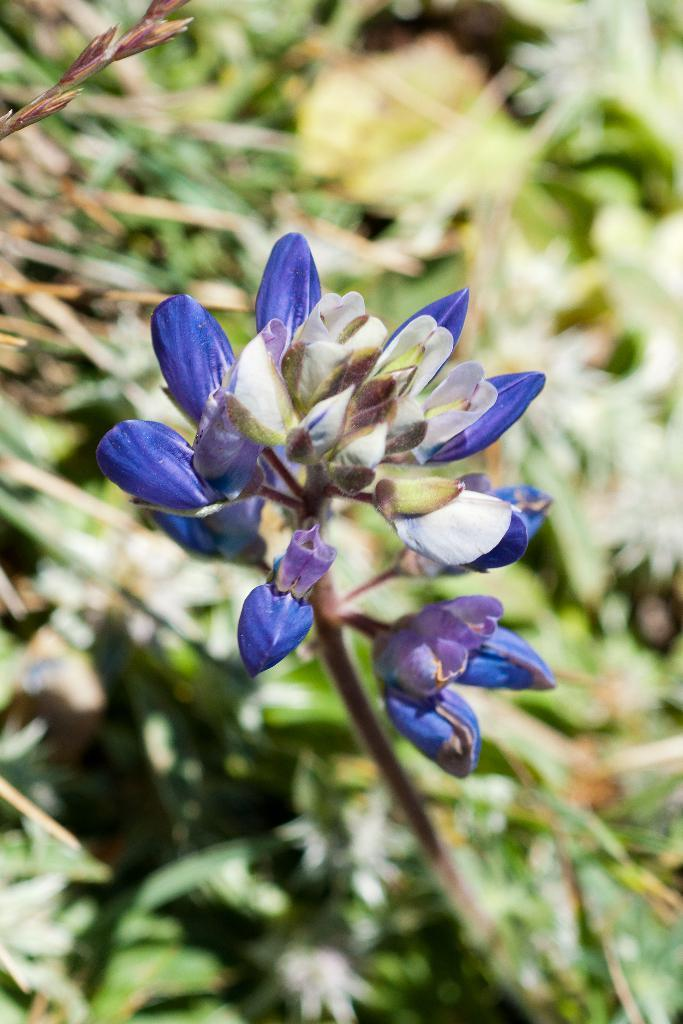What type of flowers can be seen in the foreground of the image? There are purple color flowers in the foreground of the image. What part of the flowers are visible besides the petals? The flowers have stems. What can be seen in the background of the image? There is greenery visible in the background of the image. What type of game is being played in the background of the image? There is no game present in the image; it features flowers in the foreground and greenery in the background. 